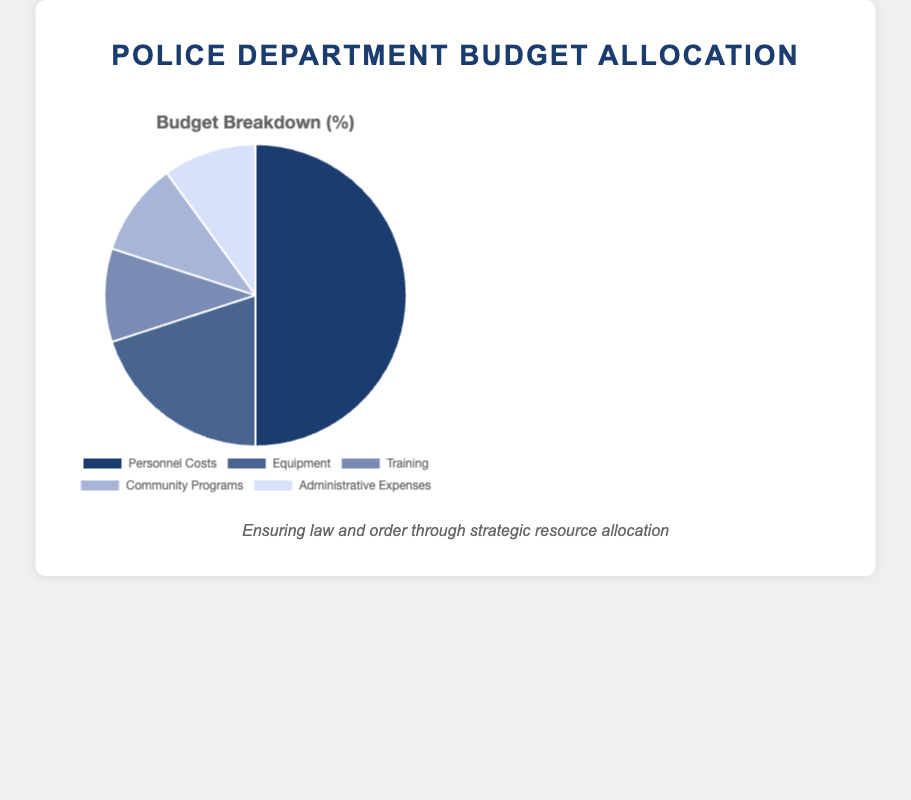Which budget category has the highest allocation? By looking at the figure, "Personnel Costs" has the largest slice of the pie chart, indicating it has the highest allocation of the budget.
Answer: Personnel Costs What is the total percentage allocation for Training and Community Programs combined? Training and Community Programs each have an allocation of 10%. Adding these two percentages together gives us 10% + 10% = 20%.
Answer: 20% How much more is allocated to Equipment compared to Administrative Expenses? Equipment has a 20% allocation, while Administrative Expenses have a 10% allocation. The difference between these allocations is 20% - 10% = 10%.
Answer: 10% Is the allocation for Equipment greater than the combined allocation for Training and Community Programs? The Equipment allocation is 20%. The combined allocation for Training and Community Programs is 10% + 10% = 20%. Thus, the allocation for Equipment is equal to the combined allocation for Training and Community Programs.
Answer: No What fraction of the budget is allocated to Personnel Costs? Personnel Costs take up 50% of the budget, represented as a fraction, this is 50/100 = 1/2.
Answer: 1/2 Calculate the average percentage allocation for categories other than Personnel Costs. The allocations for categories other than Personnel Costs are Equipment (20%), Training (10%), Community Programs (10%), and Administrative Expenses (10%). The sum of these percentages is 20% + 10% + 10% + 10% = 50%. The average is 50% / 4 categories = 12.5%.
Answer: 12.5% Which budget allocation category is represented by the lightest-colored slice in the pie chart? By looking at the color legend, the lightest color represents Administrative Expenses.
Answer: Administrative Expenses Compare the budget allocation for Community Programs to Training. Both Community Programs and Training have the same allocation of 10%.
Answer: Equal What percentage of the budget is allocated to non-operational expenses (Training, Community Programs, Administrative Expenses)? The allocations for non-operational expenses are Training (10%), Community Programs (10%), and Administrative Expenses (10%). Summing these gives us 10% + 10% + 10% = 30%.
Answer: 30% Determine the difference in budget allocation between the highest and lowest categories. The highest allocation is for Personnel Costs at 50%, and the lowest allocations are Training, Community Programs, and Administrative Expenses each at 10%. The difference is 50% - 10% = 40%.
Answer: 40% 